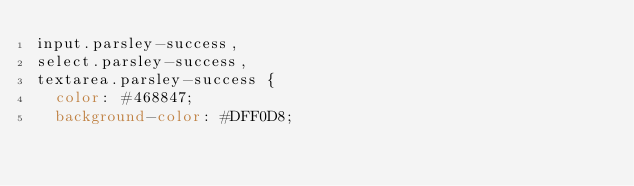Convert code to text. <code><loc_0><loc_0><loc_500><loc_500><_CSS_>input.parsley-success,
select.parsley-success,
textarea.parsley-success {
  color: #468847;
  background-color: #DFF0D8;</code> 